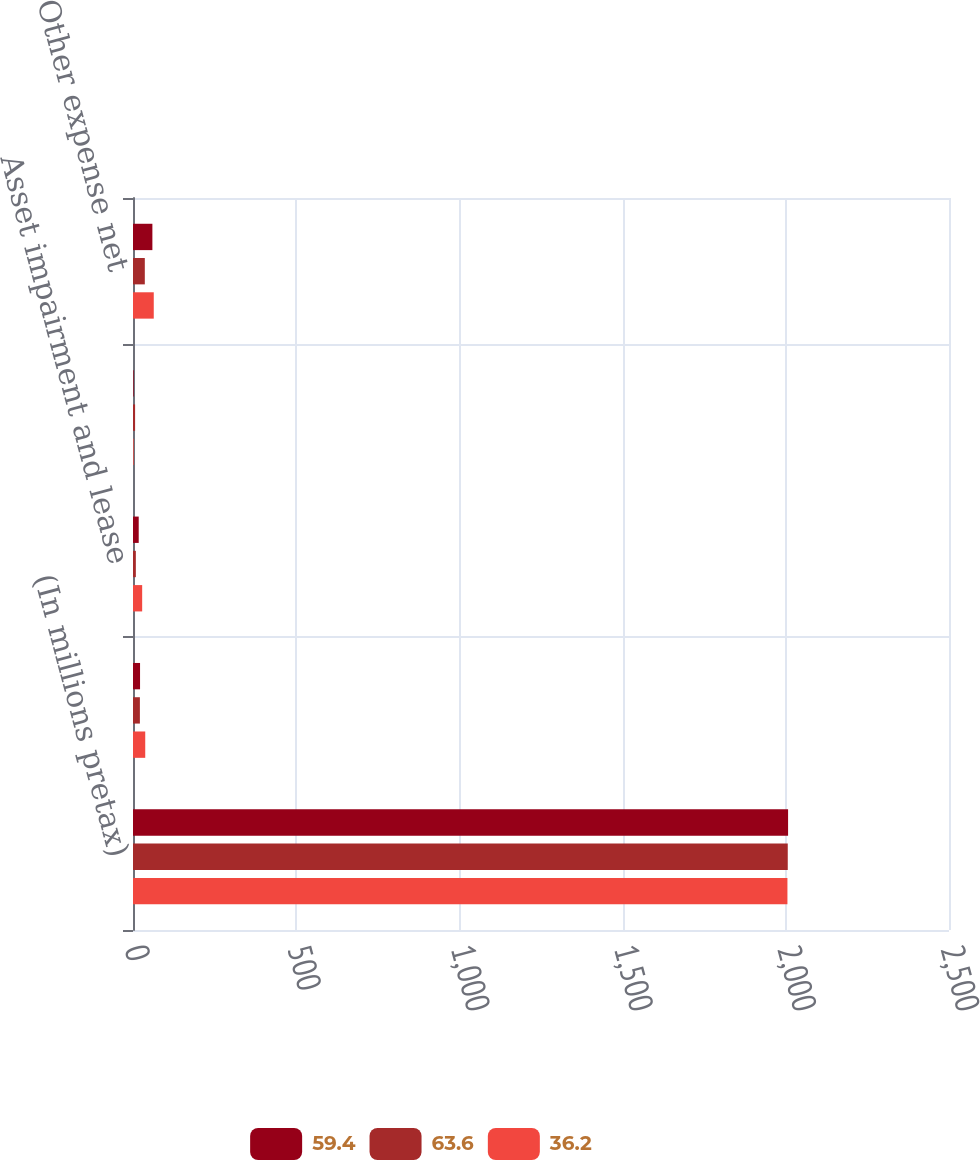<chart> <loc_0><loc_0><loc_500><loc_500><stacked_bar_chart><ecel><fcel>(In millions pretax)<fcel>Restructuring costs<fcel>Asset impairment and lease<fcel>Other items<fcel>Other expense net<nl><fcel>59.4<fcel>2007<fcel>21.6<fcel>17.5<fcel>1.9<fcel>59.4<nl><fcel>63.6<fcel>2006<fcel>21.1<fcel>8.7<fcel>6.4<fcel>36.2<nl><fcel>36.2<fcel>2005<fcel>37.5<fcel>28.1<fcel>2<fcel>63.6<nl></chart> 